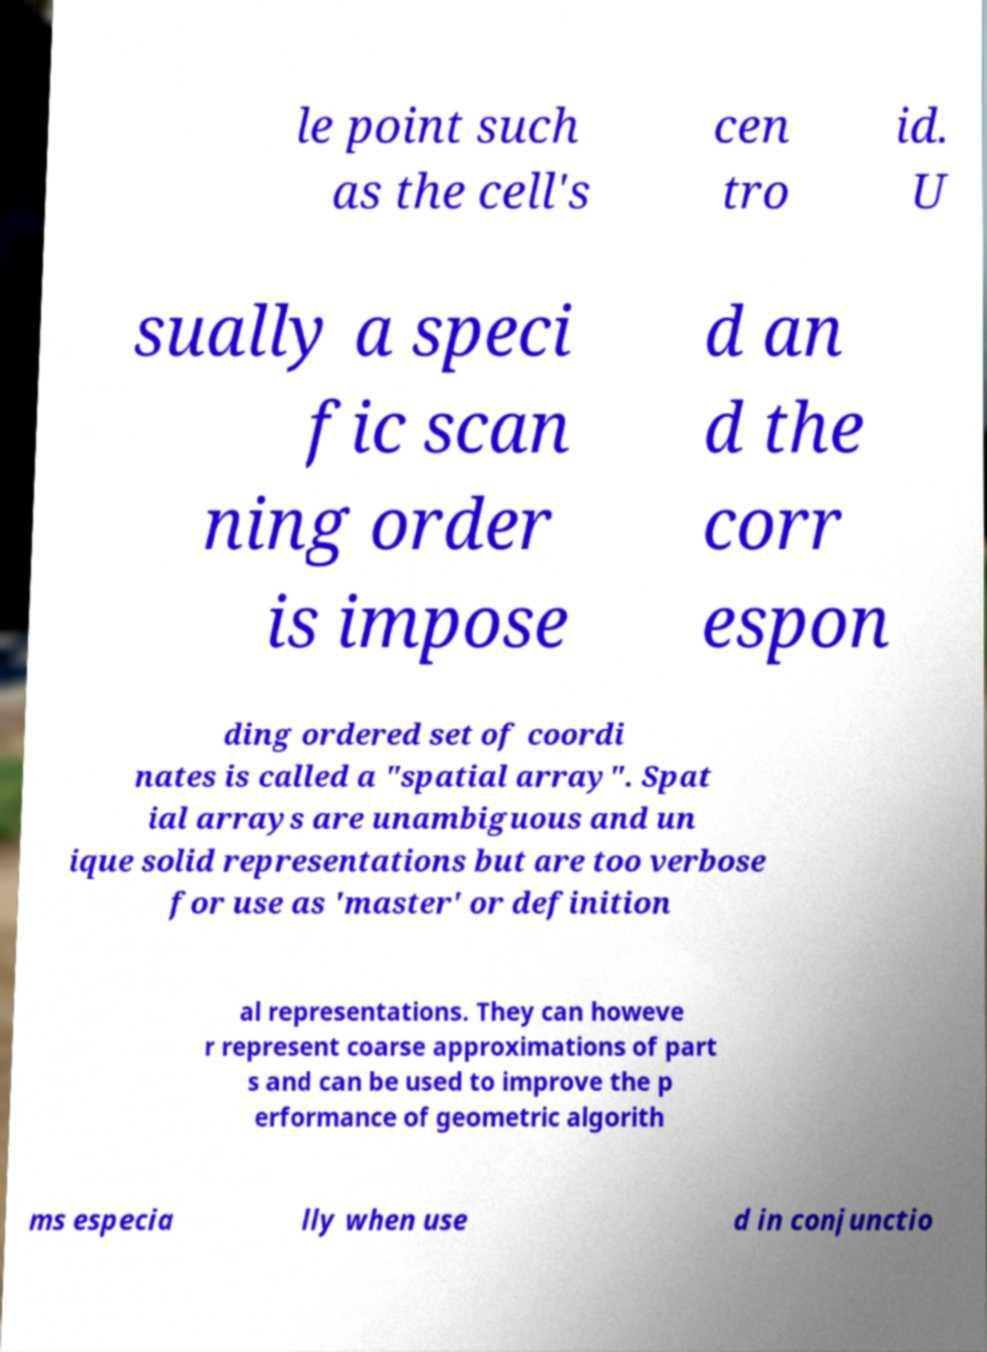Could you assist in decoding the text presented in this image and type it out clearly? le point such as the cell's cen tro id. U sually a speci fic scan ning order is impose d an d the corr espon ding ordered set of coordi nates is called a "spatial array". Spat ial arrays are unambiguous and un ique solid representations but are too verbose for use as 'master' or definition al representations. They can howeve r represent coarse approximations of part s and can be used to improve the p erformance of geometric algorith ms especia lly when use d in conjunctio 